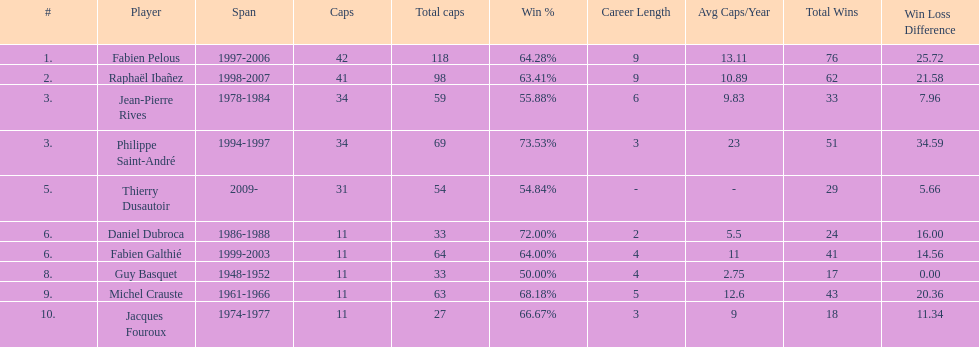What was the length of fabien pelous' tenure as captain for the french national rugby team? 9 years. 